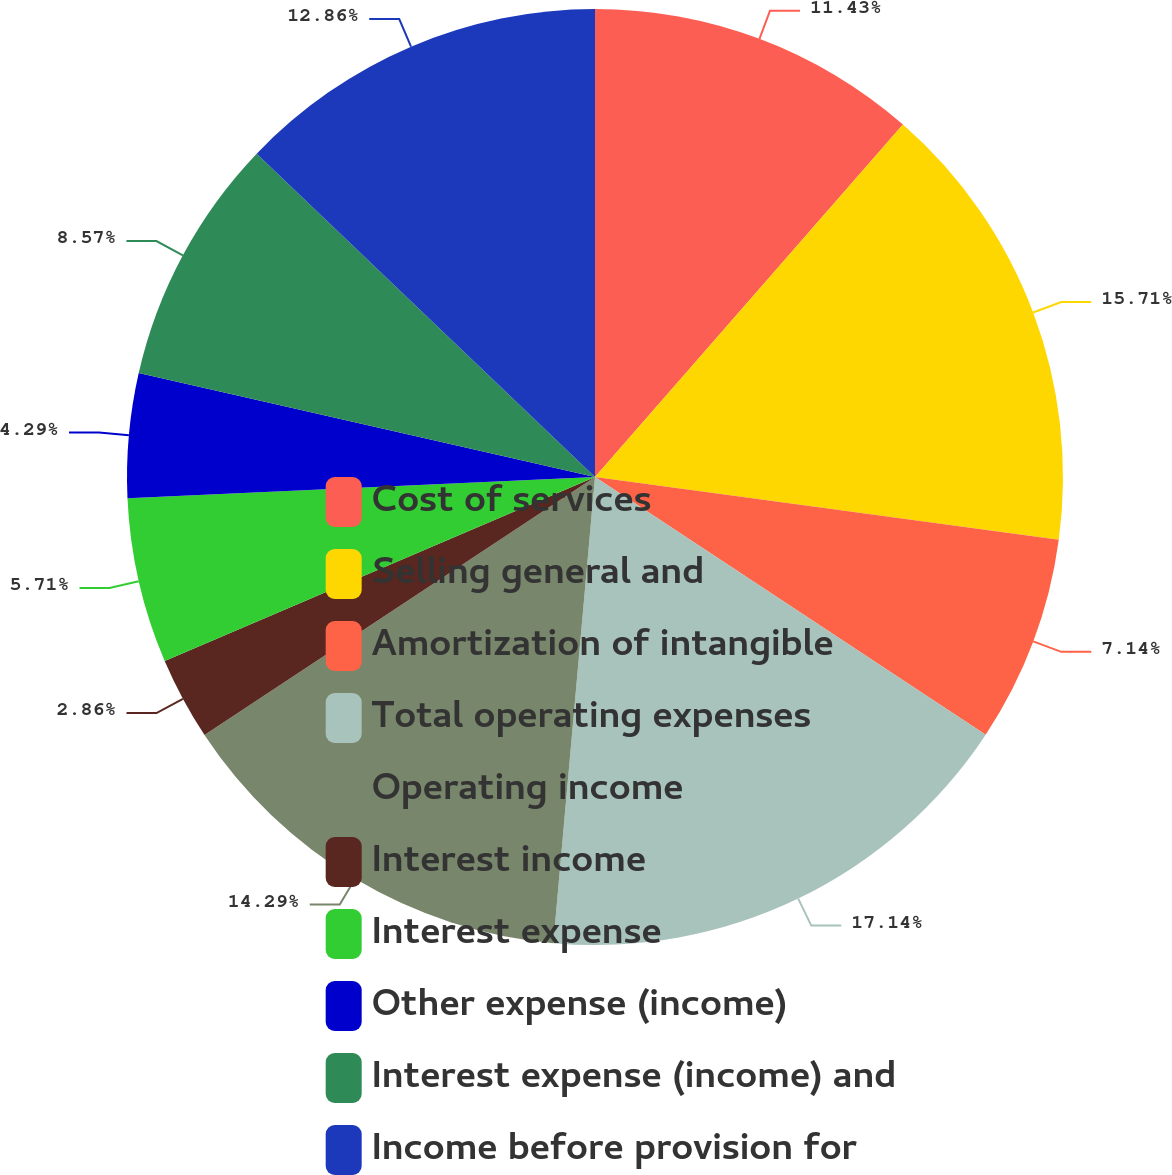Convert chart. <chart><loc_0><loc_0><loc_500><loc_500><pie_chart><fcel>Cost of services<fcel>Selling general and<fcel>Amortization of intangible<fcel>Total operating expenses<fcel>Operating income<fcel>Interest income<fcel>Interest expense<fcel>Other expense (income)<fcel>Interest expense (income) and<fcel>Income before provision for<nl><fcel>11.43%<fcel>15.71%<fcel>7.14%<fcel>17.14%<fcel>14.29%<fcel>2.86%<fcel>5.71%<fcel>4.29%<fcel>8.57%<fcel>12.86%<nl></chart> 